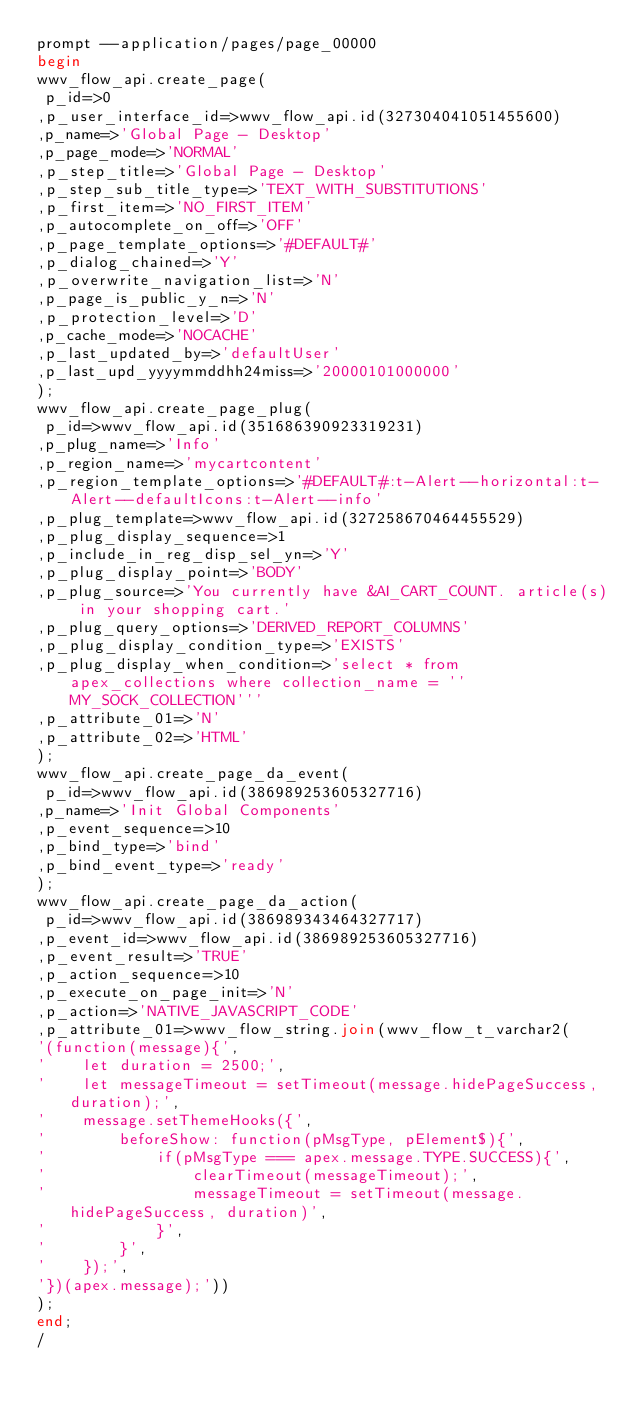<code> <loc_0><loc_0><loc_500><loc_500><_SQL_>prompt --application/pages/page_00000beginwwv_flow_api.create_page( p_id=>0,p_user_interface_id=>wwv_flow_api.id(327304041051455600),p_name=>'Global Page - Desktop',p_page_mode=>'NORMAL',p_step_title=>'Global Page - Desktop',p_step_sub_title_type=>'TEXT_WITH_SUBSTITUTIONS',p_first_item=>'NO_FIRST_ITEM',p_autocomplete_on_off=>'OFF',p_page_template_options=>'#DEFAULT#',p_dialog_chained=>'Y',p_overwrite_navigation_list=>'N',p_page_is_public_y_n=>'N',p_protection_level=>'D',p_cache_mode=>'NOCACHE',p_last_updated_by=>'defaultUser',p_last_upd_yyyymmddhh24miss=>'20000101000000');wwv_flow_api.create_page_plug( p_id=>wwv_flow_api.id(351686390923319231),p_plug_name=>'Info',p_region_name=>'mycartcontent',p_region_template_options=>'#DEFAULT#:t-Alert--horizontal:t-Alert--defaultIcons:t-Alert--info',p_plug_template=>wwv_flow_api.id(327258670464455529),p_plug_display_sequence=>1,p_include_in_reg_disp_sel_yn=>'Y',p_plug_display_point=>'BODY',p_plug_source=>'You currently have &AI_CART_COUNT. article(s) in your shopping cart.',p_plug_query_options=>'DERIVED_REPORT_COLUMNS',p_plug_display_condition_type=>'EXISTS',p_plug_display_when_condition=>'select * from apex_collections where collection_name = ''MY_SOCK_COLLECTION''',p_attribute_01=>'N',p_attribute_02=>'HTML');wwv_flow_api.create_page_da_event( p_id=>wwv_flow_api.id(386989253605327716),p_name=>'Init Global Components',p_event_sequence=>10,p_bind_type=>'bind',p_bind_event_type=>'ready');wwv_flow_api.create_page_da_action( p_id=>wwv_flow_api.id(386989343464327717),p_event_id=>wwv_flow_api.id(386989253605327716),p_event_result=>'TRUE',p_action_sequence=>10,p_execute_on_page_init=>'N',p_action=>'NATIVE_JAVASCRIPT_CODE',p_attribute_01=>wwv_flow_string.join(wwv_flow_t_varchar2('(function(message){','    let duration = 2500;','    let messageTimeout = setTimeout(message.hidePageSuccess, duration);','    message.setThemeHooks({','        beforeShow: function(pMsgType, pElement$){','            if(pMsgType === apex.message.TYPE.SUCCESS){','                clearTimeout(messageTimeout);','                messageTimeout = setTimeout(message.hidePageSuccess, duration)','            }','        }','    });','})(apex.message);')));end;/</code> 